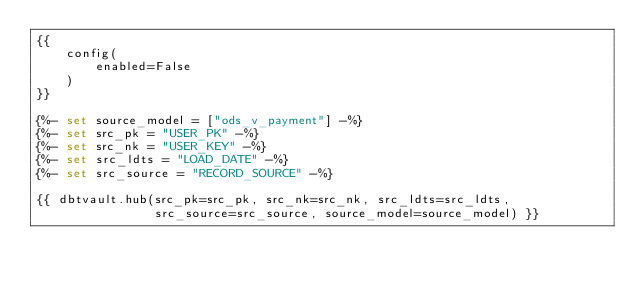Convert code to text. <code><loc_0><loc_0><loc_500><loc_500><_SQL_>{{
    config(
        enabled=False
    )
}}

{%- set source_model = ["ods_v_payment"] -%}
{%- set src_pk = "USER_PK" -%}
{%- set src_nk = "USER_KEY" -%}
{%- set src_ldts = "LOAD_DATE" -%}
{%- set src_source = "RECORD_SOURCE" -%}

{{ dbtvault.hub(src_pk=src_pk, src_nk=src_nk, src_ldts=src_ldts,
                src_source=src_source, source_model=source_model) }}</code> 